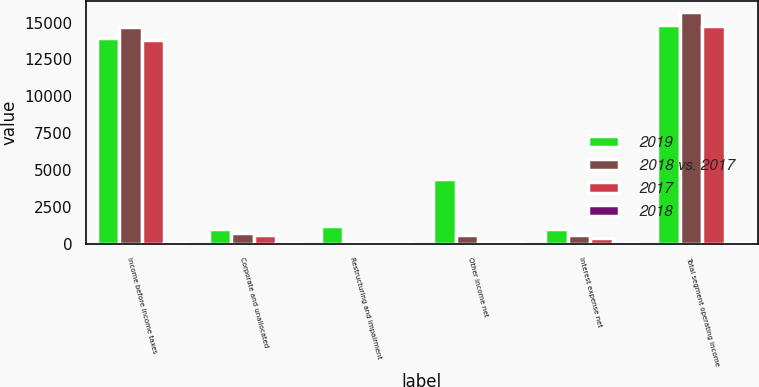<chart> <loc_0><loc_0><loc_500><loc_500><stacked_bar_chart><ecel><fcel>Income before income taxes<fcel>Corporate and unallocated<fcel>Restructuring and impairment<fcel>Other income net<fcel>Interest expense net<fcel>Total segment operating income<nl><fcel>2019<fcel>13944<fcel>987<fcel>1183<fcel>4357<fcel>978<fcel>14868<nl><fcel>2018 vs. 2017<fcel>14729<fcel>744<fcel>33<fcel>601<fcel>574<fcel>15689<nl><fcel>2017<fcel>13788<fcel>582<fcel>98<fcel>78<fcel>385<fcel>14775<nl><fcel>2018<fcel>5<fcel>33<fcel>100<fcel>100<fcel>70<fcel>5<nl></chart> 